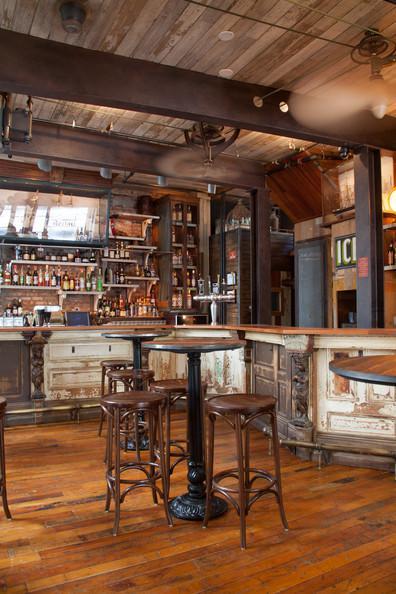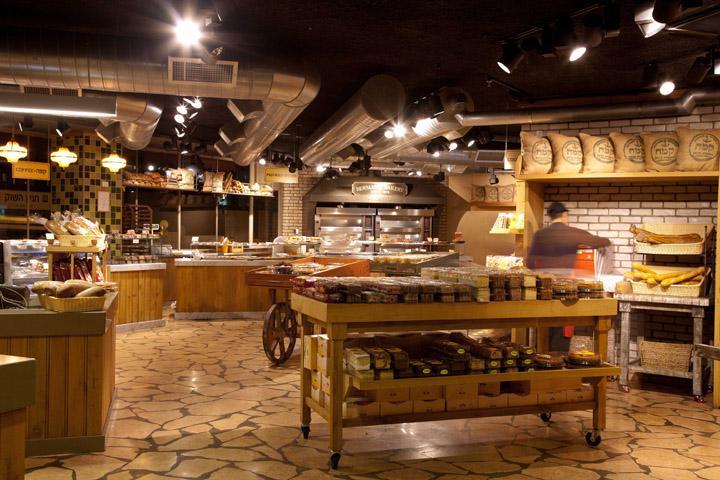The first image is the image on the left, the second image is the image on the right. Examine the images to the left and right. Is the description "there is exactly one person in the image on the right." accurate? Answer yes or no. Yes. The first image is the image on the left, the second image is the image on the right. Considering the images on both sides, is "An image shows a bakery with a natural tan stone-look floor." valid? Answer yes or no. Yes. 